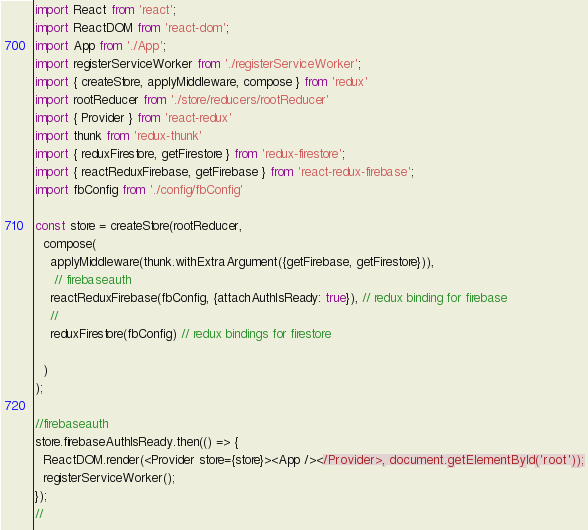<code> <loc_0><loc_0><loc_500><loc_500><_JavaScript_>import React from 'react';
import ReactDOM from 'react-dom';
import App from './App';
import registerServiceWorker from './registerServiceWorker';
import { createStore, applyMiddleware, compose } from 'redux'
import rootReducer from './store/reducers/rootReducer'
import { Provider } from 'react-redux'
import thunk from 'redux-thunk'
import { reduxFirestore, getFirestore } from 'redux-firestore';
import { reactReduxFirebase, getFirebase } from 'react-redux-firebase';
import fbConfig from './config/fbConfig'

const store = createStore(rootReducer,
  compose(
    applyMiddleware(thunk.withExtraArgument({getFirebase, getFirestore})),
     // firebaseauth
    reactReduxFirebase(fbConfig, {attachAuthIsReady: true}), // redux binding for firebase
    //
    reduxFirestore(fbConfig) // redux bindings for firestore
    
  )
);

//firebaseauth
store.firebaseAuthIsReady.then(() => {
  ReactDOM.render(<Provider store={store}><App /></Provider>, document.getElementById('root'));
  registerServiceWorker();
});
//

</code> 